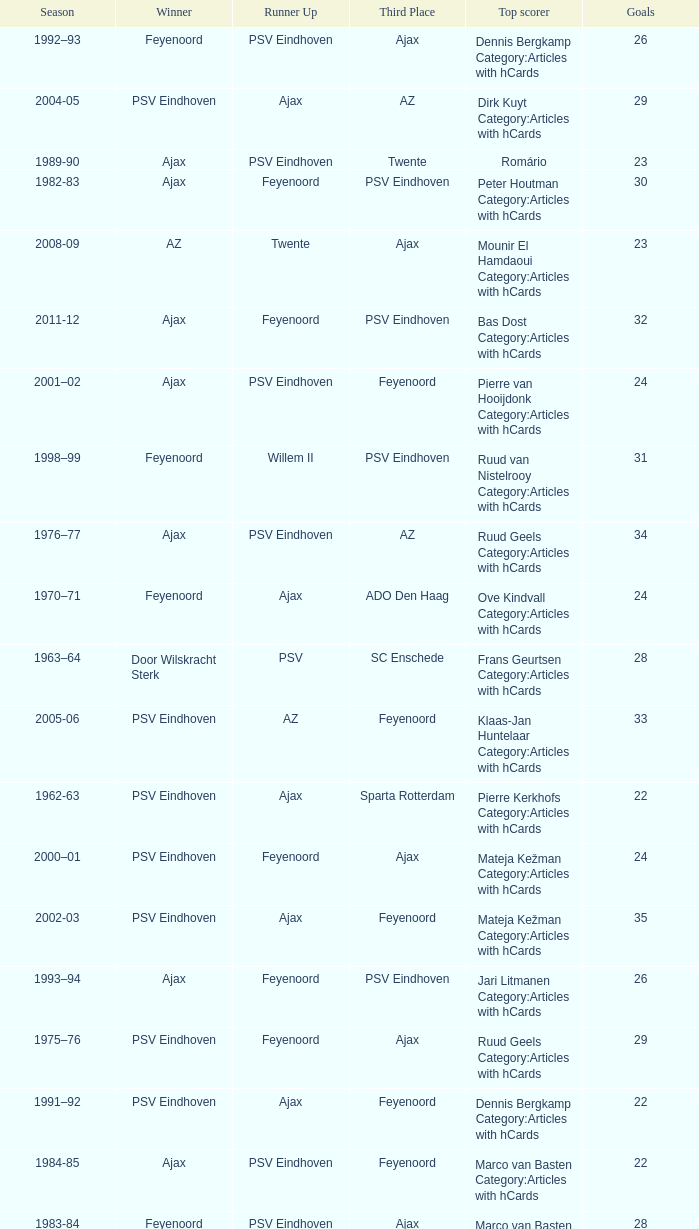When nac breda came in third place and psv eindhoven was the winner who is the top scorer? Klaas-Jan Huntelaar Category:Articles with hCards. 